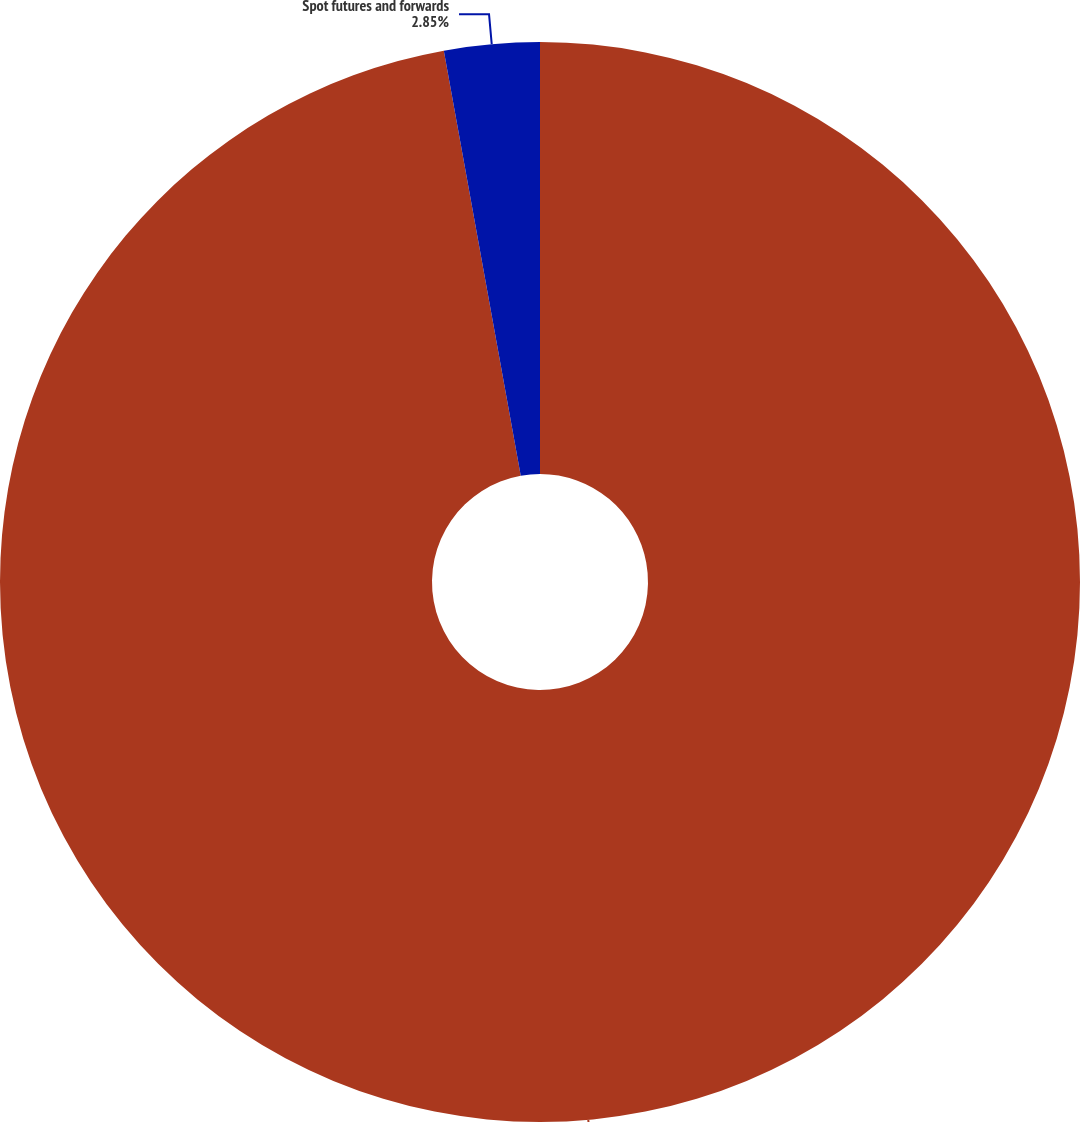<chart> <loc_0><loc_0><loc_500><loc_500><pie_chart><fcel>Swaps<fcel>Spot futures and forwards<nl><fcel>97.15%<fcel>2.85%<nl></chart> 